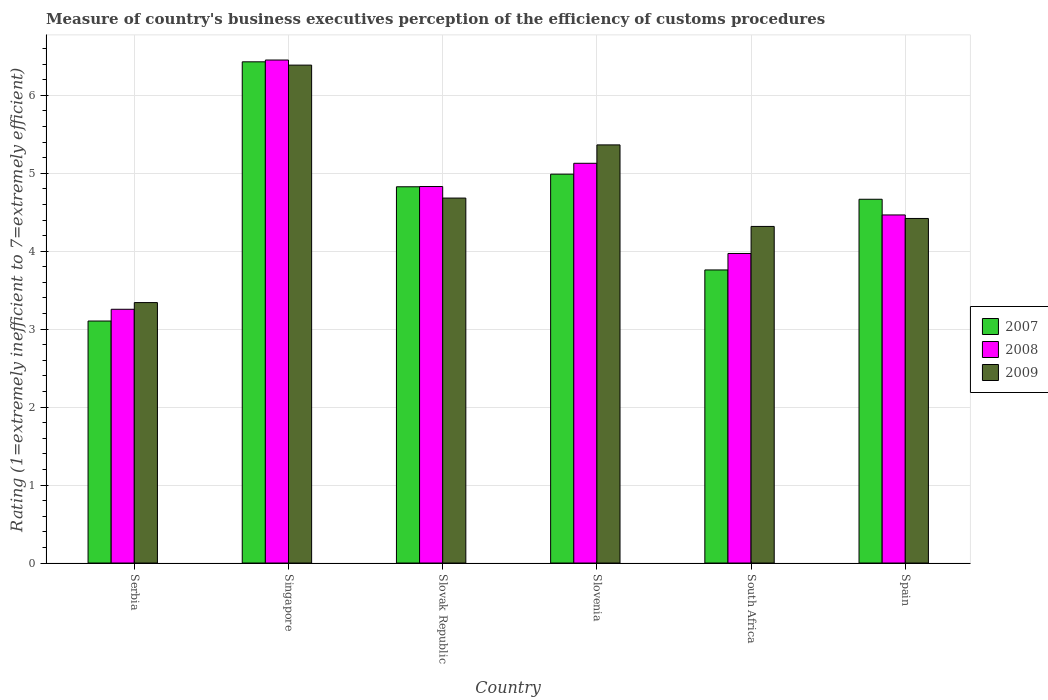How many groups of bars are there?
Your response must be concise. 6. Are the number of bars per tick equal to the number of legend labels?
Offer a very short reply. Yes. How many bars are there on the 5th tick from the left?
Your response must be concise. 3. What is the label of the 2nd group of bars from the left?
Provide a succinct answer. Singapore. What is the rating of the efficiency of customs procedure in 2007 in Slovak Republic?
Keep it short and to the point. 4.83. Across all countries, what is the maximum rating of the efficiency of customs procedure in 2009?
Make the answer very short. 6.39. Across all countries, what is the minimum rating of the efficiency of customs procedure in 2009?
Offer a terse response. 3.34. In which country was the rating of the efficiency of customs procedure in 2009 maximum?
Give a very brief answer. Singapore. In which country was the rating of the efficiency of customs procedure in 2008 minimum?
Your answer should be compact. Serbia. What is the total rating of the efficiency of customs procedure in 2007 in the graph?
Your answer should be compact. 27.78. What is the difference between the rating of the efficiency of customs procedure in 2007 in Slovak Republic and that in Slovenia?
Your answer should be very brief. -0.16. What is the difference between the rating of the efficiency of customs procedure in 2008 in Slovak Republic and the rating of the efficiency of customs procedure in 2007 in South Africa?
Ensure brevity in your answer.  1.07. What is the average rating of the efficiency of customs procedure in 2007 per country?
Keep it short and to the point. 4.63. What is the difference between the rating of the efficiency of customs procedure of/in 2007 and rating of the efficiency of customs procedure of/in 2008 in Slovenia?
Ensure brevity in your answer.  -0.14. In how many countries, is the rating of the efficiency of customs procedure in 2008 greater than 2.6?
Provide a short and direct response. 6. What is the ratio of the rating of the efficiency of customs procedure in 2009 in Serbia to that in Singapore?
Offer a terse response. 0.52. Is the rating of the efficiency of customs procedure in 2008 in Serbia less than that in Slovenia?
Offer a terse response. Yes. Is the difference between the rating of the efficiency of customs procedure in 2007 in Serbia and South Africa greater than the difference between the rating of the efficiency of customs procedure in 2008 in Serbia and South Africa?
Keep it short and to the point. Yes. What is the difference between the highest and the second highest rating of the efficiency of customs procedure in 2007?
Ensure brevity in your answer.  0.16. What is the difference between the highest and the lowest rating of the efficiency of customs procedure in 2009?
Your response must be concise. 3.05. How many bars are there?
Offer a terse response. 18. Are all the bars in the graph horizontal?
Give a very brief answer. No. How many countries are there in the graph?
Provide a succinct answer. 6. Are the values on the major ticks of Y-axis written in scientific E-notation?
Keep it short and to the point. No. Where does the legend appear in the graph?
Your response must be concise. Center right. What is the title of the graph?
Your answer should be very brief. Measure of country's business executives perception of the efficiency of customs procedures. What is the label or title of the X-axis?
Provide a short and direct response. Country. What is the label or title of the Y-axis?
Your response must be concise. Rating (1=extremely inefficient to 7=extremely efficient). What is the Rating (1=extremely inefficient to 7=extremely efficient) in 2007 in Serbia?
Your response must be concise. 3.1. What is the Rating (1=extremely inefficient to 7=extremely efficient) of 2008 in Serbia?
Your answer should be compact. 3.26. What is the Rating (1=extremely inefficient to 7=extremely efficient) of 2009 in Serbia?
Your answer should be very brief. 3.34. What is the Rating (1=extremely inefficient to 7=extremely efficient) of 2007 in Singapore?
Your response must be concise. 6.43. What is the Rating (1=extremely inefficient to 7=extremely efficient) in 2008 in Singapore?
Your response must be concise. 6.45. What is the Rating (1=extremely inefficient to 7=extremely efficient) of 2009 in Singapore?
Give a very brief answer. 6.39. What is the Rating (1=extremely inefficient to 7=extremely efficient) in 2007 in Slovak Republic?
Make the answer very short. 4.83. What is the Rating (1=extremely inefficient to 7=extremely efficient) of 2008 in Slovak Republic?
Your answer should be very brief. 4.83. What is the Rating (1=extremely inefficient to 7=extremely efficient) in 2009 in Slovak Republic?
Offer a terse response. 4.68. What is the Rating (1=extremely inefficient to 7=extremely efficient) of 2007 in Slovenia?
Provide a short and direct response. 4.99. What is the Rating (1=extremely inefficient to 7=extremely efficient) in 2008 in Slovenia?
Keep it short and to the point. 5.13. What is the Rating (1=extremely inefficient to 7=extremely efficient) of 2009 in Slovenia?
Provide a succinct answer. 5.36. What is the Rating (1=extremely inefficient to 7=extremely efficient) of 2007 in South Africa?
Provide a succinct answer. 3.76. What is the Rating (1=extremely inefficient to 7=extremely efficient) of 2008 in South Africa?
Ensure brevity in your answer.  3.97. What is the Rating (1=extremely inefficient to 7=extremely efficient) of 2009 in South Africa?
Keep it short and to the point. 4.32. What is the Rating (1=extremely inefficient to 7=extremely efficient) in 2007 in Spain?
Your response must be concise. 4.67. What is the Rating (1=extremely inefficient to 7=extremely efficient) of 2008 in Spain?
Make the answer very short. 4.47. What is the Rating (1=extremely inefficient to 7=extremely efficient) in 2009 in Spain?
Give a very brief answer. 4.42. Across all countries, what is the maximum Rating (1=extremely inefficient to 7=extremely efficient) of 2007?
Offer a terse response. 6.43. Across all countries, what is the maximum Rating (1=extremely inefficient to 7=extremely efficient) of 2008?
Keep it short and to the point. 6.45. Across all countries, what is the maximum Rating (1=extremely inefficient to 7=extremely efficient) of 2009?
Your response must be concise. 6.39. Across all countries, what is the minimum Rating (1=extremely inefficient to 7=extremely efficient) of 2007?
Your answer should be very brief. 3.1. Across all countries, what is the minimum Rating (1=extremely inefficient to 7=extremely efficient) in 2008?
Provide a short and direct response. 3.26. Across all countries, what is the minimum Rating (1=extremely inefficient to 7=extremely efficient) of 2009?
Keep it short and to the point. 3.34. What is the total Rating (1=extremely inefficient to 7=extremely efficient) of 2007 in the graph?
Your answer should be very brief. 27.78. What is the total Rating (1=extremely inefficient to 7=extremely efficient) in 2008 in the graph?
Your answer should be very brief. 28.1. What is the total Rating (1=extremely inefficient to 7=extremely efficient) of 2009 in the graph?
Make the answer very short. 28.51. What is the difference between the Rating (1=extremely inefficient to 7=extremely efficient) in 2007 in Serbia and that in Singapore?
Provide a short and direct response. -3.33. What is the difference between the Rating (1=extremely inefficient to 7=extremely efficient) of 2008 in Serbia and that in Singapore?
Your response must be concise. -3.2. What is the difference between the Rating (1=extremely inefficient to 7=extremely efficient) in 2009 in Serbia and that in Singapore?
Your response must be concise. -3.05. What is the difference between the Rating (1=extremely inefficient to 7=extremely efficient) of 2007 in Serbia and that in Slovak Republic?
Ensure brevity in your answer.  -1.72. What is the difference between the Rating (1=extremely inefficient to 7=extremely efficient) of 2008 in Serbia and that in Slovak Republic?
Provide a short and direct response. -1.57. What is the difference between the Rating (1=extremely inefficient to 7=extremely efficient) in 2009 in Serbia and that in Slovak Republic?
Provide a short and direct response. -1.34. What is the difference between the Rating (1=extremely inefficient to 7=extremely efficient) in 2007 in Serbia and that in Slovenia?
Your answer should be compact. -1.88. What is the difference between the Rating (1=extremely inefficient to 7=extremely efficient) of 2008 in Serbia and that in Slovenia?
Offer a very short reply. -1.87. What is the difference between the Rating (1=extremely inefficient to 7=extremely efficient) in 2009 in Serbia and that in Slovenia?
Your response must be concise. -2.02. What is the difference between the Rating (1=extremely inefficient to 7=extremely efficient) in 2007 in Serbia and that in South Africa?
Keep it short and to the point. -0.66. What is the difference between the Rating (1=extremely inefficient to 7=extremely efficient) of 2008 in Serbia and that in South Africa?
Offer a very short reply. -0.72. What is the difference between the Rating (1=extremely inefficient to 7=extremely efficient) of 2009 in Serbia and that in South Africa?
Give a very brief answer. -0.98. What is the difference between the Rating (1=extremely inefficient to 7=extremely efficient) of 2007 in Serbia and that in Spain?
Keep it short and to the point. -1.56. What is the difference between the Rating (1=extremely inefficient to 7=extremely efficient) in 2008 in Serbia and that in Spain?
Offer a terse response. -1.21. What is the difference between the Rating (1=extremely inefficient to 7=extremely efficient) in 2009 in Serbia and that in Spain?
Make the answer very short. -1.08. What is the difference between the Rating (1=extremely inefficient to 7=extremely efficient) of 2007 in Singapore and that in Slovak Republic?
Your answer should be compact. 1.6. What is the difference between the Rating (1=extremely inefficient to 7=extremely efficient) of 2008 in Singapore and that in Slovak Republic?
Your response must be concise. 1.62. What is the difference between the Rating (1=extremely inefficient to 7=extremely efficient) of 2009 in Singapore and that in Slovak Republic?
Your answer should be very brief. 1.71. What is the difference between the Rating (1=extremely inefficient to 7=extremely efficient) of 2007 in Singapore and that in Slovenia?
Give a very brief answer. 1.44. What is the difference between the Rating (1=extremely inefficient to 7=extremely efficient) of 2008 in Singapore and that in Slovenia?
Make the answer very short. 1.32. What is the difference between the Rating (1=extremely inefficient to 7=extremely efficient) of 2009 in Singapore and that in Slovenia?
Ensure brevity in your answer.  1.02. What is the difference between the Rating (1=extremely inefficient to 7=extremely efficient) in 2007 in Singapore and that in South Africa?
Ensure brevity in your answer.  2.67. What is the difference between the Rating (1=extremely inefficient to 7=extremely efficient) in 2008 in Singapore and that in South Africa?
Your response must be concise. 2.48. What is the difference between the Rating (1=extremely inefficient to 7=extremely efficient) in 2009 in Singapore and that in South Africa?
Provide a short and direct response. 2.07. What is the difference between the Rating (1=extremely inefficient to 7=extremely efficient) in 2007 in Singapore and that in Spain?
Your answer should be compact. 1.76. What is the difference between the Rating (1=extremely inefficient to 7=extremely efficient) of 2008 in Singapore and that in Spain?
Your answer should be very brief. 1.99. What is the difference between the Rating (1=extremely inefficient to 7=extremely efficient) of 2009 in Singapore and that in Spain?
Your answer should be very brief. 1.97. What is the difference between the Rating (1=extremely inefficient to 7=extremely efficient) of 2007 in Slovak Republic and that in Slovenia?
Provide a short and direct response. -0.16. What is the difference between the Rating (1=extremely inefficient to 7=extremely efficient) of 2008 in Slovak Republic and that in Slovenia?
Your answer should be very brief. -0.3. What is the difference between the Rating (1=extremely inefficient to 7=extremely efficient) in 2009 in Slovak Republic and that in Slovenia?
Give a very brief answer. -0.68. What is the difference between the Rating (1=extremely inefficient to 7=extremely efficient) of 2007 in Slovak Republic and that in South Africa?
Keep it short and to the point. 1.07. What is the difference between the Rating (1=extremely inefficient to 7=extremely efficient) of 2008 in Slovak Republic and that in South Africa?
Ensure brevity in your answer.  0.86. What is the difference between the Rating (1=extremely inefficient to 7=extremely efficient) in 2009 in Slovak Republic and that in South Africa?
Ensure brevity in your answer.  0.36. What is the difference between the Rating (1=extremely inefficient to 7=extremely efficient) in 2007 in Slovak Republic and that in Spain?
Keep it short and to the point. 0.16. What is the difference between the Rating (1=extremely inefficient to 7=extremely efficient) in 2008 in Slovak Republic and that in Spain?
Ensure brevity in your answer.  0.36. What is the difference between the Rating (1=extremely inefficient to 7=extremely efficient) of 2009 in Slovak Republic and that in Spain?
Your answer should be compact. 0.26. What is the difference between the Rating (1=extremely inefficient to 7=extremely efficient) of 2007 in Slovenia and that in South Africa?
Ensure brevity in your answer.  1.23. What is the difference between the Rating (1=extremely inefficient to 7=extremely efficient) in 2008 in Slovenia and that in South Africa?
Your response must be concise. 1.16. What is the difference between the Rating (1=extremely inefficient to 7=extremely efficient) of 2009 in Slovenia and that in South Africa?
Offer a very short reply. 1.05. What is the difference between the Rating (1=extremely inefficient to 7=extremely efficient) in 2007 in Slovenia and that in Spain?
Provide a short and direct response. 0.32. What is the difference between the Rating (1=extremely inefficient to 7=extremely efficient) of 2008 in Slovenia and that in Spain?
Your answer should be very brief. 0.66. What is the difference between the Rating (1=extremely inefficient to 7=extremely efficient) of 2009 in Slovenia and that in Spain?
Offer a terse response. 0.94. What is the difference between the Rating (1=extremely inefficient to 7=extremely efficient) of 2007 in South Africa and that in Spain?
Give a very brief answer. -0.91. What is the difference between the Rating (1=extremely inefficient to 7=extremely efficient) in 2008 in South Africa and that in Spain?
Ensure brevity in your answer.  -0.49. What is the difference between the Rating (1=extremely inefficient to 7=extremely efficient) in 2009 in South Africa and that in Spain?
Provide a succinct answer. -0.1. What is the difference between the Rating (1=extremely inefficient to 7=extremely efficient) of 2007 in Serbia and the Rating (1=extremely inefficient to 7=extremely efficient) of 2008 in Singapore?
Keep it short and to the point. -3.35. What is the difference between the Rating (1=extremely inefficient to 7=extremely efficient) of 2007 in Serbia and the Rating (1=extremely inefficient to 7=extremely efficient) of 2009 in Singapore?
Your response must be concise. -3.28. What is the difference between the Rating (1=extremely inefficient to 7=extremely efficient) in 2008 in Serbia and the Rating (1=extremely inefficient to 7=extremely efficient) in 2009 in Singapore?
Provide a short and direct response. -3.13. What is the difference between the Rating (1=extremely inefficient to 7=extremely efficient) of 2007 in Serbia and the Rating (1=extremely inefficient to 7=extremely efficient) of 2008 in Slovak Republic?
Give a very brief answer. -1.73. What is the difference between the Rating (1=extremely inefficient to 7=extremely efficient) in 2007 in Serbia and the Rating (1=extremely inefficient to 7=extremely efficient) in 2009 in Slovak Republic?
Ensure brevity in your answer.  -1.58. What is the difference between the Rating (1=extremely inefficient to 7=extremely efficient) of 2008 in Serbia and the Rating (1=extremely inefficient to 7=extremely efficient) of 2009 in Slovak Republic?
Provide a succinct answer. -1.43. What is the difference between the Rating (1=extremely inefficient to 7=extremely efficient) of 2007 in Serbia and the Rating (1=extremely inefficient to 7=extremely efficient) of 2008 in Slovenia?
Keep it short and to the point. -2.02. What is the difference between the Rating (1=extremely inefficient to 7=extremely efficient) in 2007 in Serbia and the Rating (1=extremely inefficient to 7=extremely efficient) in 2009 in Slovenia?
Provide a succinct answer. -2.26. What is the difference between the Rating (1=extremely inefficient to 7=extremely efficient) in 2008 in Serbia and the Rating (1=extremely inefficient to 7=extremely efficient) in 2009 in Slovenia?
Your answer should be compact. -2.11. What is the difference between the Rating (1=extremely inefficient to 7=extremely efficient) of 2007 in Serbia and the Rating (1=extremely inefficient to 7=extremely efficient) of 2008 in South Africa?
Ensure brevity in your answer.  -0.87. What is the difference between the Rating (1=extremely inefficient to 7=extremely efficient) of 2007 in Serbia and the Rating (1=extremely inefficient to 7=extremely efficient) of 2009 in South Africa?
Make the answer very short. -1.21. What is the difference between the Rating (1=extremely inefficient to 7=extremely efficient) of 2008 in Serbia and the Rating (1=extremely inefficient to 7=extremely efficient) of 2009 in South Africa?
Offer a very short reply. -1.06. What is the difference between the Rating (1=extremely inefficient to 7=extremely efficient) of 2007 in Serbia and the Rating (1=extremely inefficient to 7=extremely efficient) of 2008 in Spain?
Offer a terse response. -1.36. What is the difference between the Rating (1=extremely inefficient to 7=extremely efficient) in 2007 in Serbia and the Rating (1=extremely inefficient to 7=extremely efficient) in 2009 in Spain?
Ensure brevity in your answer.  -1.32. What is the difference between the Rating (1=extremely inefficient to 7=extremely efficient) of 2008 in Serbia and the Rating (1=extremely inefficient to 7=extremely efficient) of 2009 in Spain?
Your answer should be very brief. -1.17. What is the difference between the Rating (1=extremely inefficient to 7=extremely efficient) in 2007 in Singapore and the Rating (1=extremely inefficient to 7=extremely efficient) in 2008 in Slovak Republic?
Provide a succinct answer. 1.6. What is the difference between the Rating (1=extremely inefficient to 7=extremely efficient) in 2007 in Singapore and the Rating (1=extremely inefficient to 7=extremely efficient) in 2009 in Slovak Republic?
Give a very brief answer. 1.75. What is the difference between the Rating (1=extremely inefficient to 7=extremely efficient) in 2008 in Singapore and the Rating (1=extremely inefficient to 7=extremely efficient) in 2009 in Slovak Republic?
Provide a succinct answer. 1.77. What is the difference between the Rating (1=extremely inefficient to 7=extremely efficient) of 2007 in Singapore and the Rating (1=extremely inefficient to 7=extremely efficient) of 2008 in Slovenia?
Offer a very short reply. 1.3. What is the difference between the Rating (1=extremely inefficient to 7=extremely efficient) of 2007 in Singapore and the Rating (1=extremely inefficient to 7=extremely efficient) of 2009 in Slovenia?
Make the answer very short. 1.07. What is the difference between the Rating (1=extremely inefficient to 7=extremely efficient) of 2008 in Singapore and the Rating (1=extremely inefficient to 7=extremely efficient) of 2009 in Slovenia?
Ensure brevity in your answer.  1.09. What is the difference between the Rating (1=extremely inefficient to 7=extremely efficient) of 2007 in Singapore and the Rating (1=extremely inefficient to 7=extremely efficient) of 2008 in South Africa?
Give a very brief answer. 2.46. What is the difference between the Rating (1=extremely inefficient to 7=extremely efficient) in 2007 in Singapore and the Rating (1=extremely inefficient to 7=extremely efficient) in 2009 in South Africa?
Keep it short and to the point. 2.11. What is the difference between the Rating (1=extremely inefficient to 7=extremely efficient) of 2008 in Singapore and the Rating (1=extremely inefficient to 7=extremely efficient) of 2009 in South Africa?
Provide a short and direct response. 2.13. What is the difference between the Rating (1=extremely inefficient to 7=extremely efficient) of 2007 in Singapore and the Rating (1=extremely inefficient to 7=extremely efficient) of 2008 in Spain?
Keep it short and to the point. 1.96. What is the difference between the Rating (1=extremely inefficient to 7=extremely efficient) of 2007 in Singapore and the Rating (1=extremely inefficient to 7=extremely efficient) of 2009 in Spain?
Provide a succinct answer. 2.01. What is the difference between the Rating (1=extremely inefficient to 7=extremely efficient) in 2008 in Singapore and the Rating (1=extremely inefficient to 7=extremely efficient) in 2009 in Spain?
Ensure brevity in your answer.  2.03. What is the difference between the Rating (1=extremely inefficient to 7=extremely efficient) in 2007 in Slovak Republic and the Rating (1=extremely inefficient to 7=extremely efficient) in 2008 in Slovenia?
Your answer should be compact. -0.3. What is the difference between the Rating (1=extremely inefficient to 7=extremely efficient) of 2007 in Slovak Republic and the Rating (1=extremely inefficient to 7=extremely efficient) of 2009 in Slovenia?
Your answer should be very brief. -0.54. What is the difference between the Rating (1=extremely inefficient to 7=extremely efficient) in 2008 in Slovak Republic and the Rating (1=extremely inefficient to 7=extremely efficient) in 2009 in Slovenia?
Provide a succinct answer. -0.53. What is the difference between the Rating (1=extremely inefficient to 7=extremely efficient) of 2007 in Slovak Republic and the Rating (1=extremely inefficient to 7=extremely efficient) of 2008 in South Africa?
Your answer should be compact. 0.86. What is the difference between the Rating (1=extremely inefficient to 7=extremely efficient) in 2007 in Slovak Republic and the Rating (1=extremely inefficient to 7=extremely efficient) in 2009 in South Africa?
Provide a short and direct response. 0.51. What is the difference between the Rating (1=extremely inefficient to 7=extremely efficient) of 2008 in Slovak Republic and the Rating (1=extremely inefficient to 7=extremely efficient) of 2009 in South Africa?
Provide a succinct answer. 0.51. What is the difference between the Rating (1=extremely inefficient to 7=extremely efficient) in 2007 in Slovak Republic and the Rating (1=extremely inefficient to 7=extremely efficient) in 2008 in Spain?
Your response must be concise. 0.36. What is the difference between the Rating (1=extremely inefficient to 7=extremely efficient) of 2007 in Slovak Republic and the Rating (1=extremely inefficient to 7=extremely efficient) of 2009 in Spain?
Your answer should be very brief. 0.41. What is the difference between the Rating (1=extremely inefficient to 7=extremely efficient) of 2008 in Slovak Republic and the Rating (1=extremely inefficient to 7=extremely efficient) of 2009 in Spain?
Give a very brief answer. 0.41. What is the difference between the Rating (1=extremely inefficient to 7=extremely efficient) of 2007 in Slovenia and the Rating (1=extremely inefficient to 7=extremely efficient) of 2008 in South Africa?
Keep it short and to the point. 1.02. What is the difference between the Rating (1=extremely inefficient to 7=extremely efficient) of 2007 in Slovenia and the Rating (1=extremely inefficient to 7=extremely efficient) of 2009 in South Africa?
Offer a terse response. 0.67. What is the difference between the Rating (1=extremely inefficient to 7=extremely efficient) in 2008 in Slovenia and the Rating (1=extremely inefficient to 7=extremely efficient) in 2009 in South Africa?
Provide a short and direct response. 0.81. What is the difference between the Rating (1=extremely inefficient to 7=extremely efficient) in 2007 in Slovenia and the Rating (1=extremely inefficient to 7=extremely efficient) in 2008 in Spain?
Provide a succinct answer. 0.52. What is the difference between the Rating (1=extremely inefficient to 7=extremely efficient) in 2007 in Slovenia and the Rating (1=extremely inefficient to 7=extremely efficient) in 2009 in Spain?
Provide a succinct answer. 0.57. What is the difference between the Rating (1=extremely inefficient to 7=extremely efficient) in 2008 in Slovenia and the Rating (1=extremely inefficient to 7=extremely efficient) in 2009 in Spain?
Your answer should be very brief. 0.71. What is the difference between the Rating (1=extremely inefficient to 7=extremely efficient) in 2007 in South Africa and the Rating (1=extremely inefficient to 7=extremely efficient) in 2008 in Spain?
Your answer should be very brief. -0.71. What is the difference between the Rating (1=extremely inefficient to 7=extremely efficient) in 2007 in South Africa and the Rating (1=extremely inefficient to 7=extremely efficient) in 2009 in Spain?
Offer a terse response. -0.66. What is the difference between the Rating (1=extremely inefficient to 7=extremely efficient) in 2008 in South Africa and the Rating (1=extremely inefficient to 7=extremely efficient) in 2009 in Spain?
Keep it short and to the point. -0.45. What is the average Rating (1=extremely inefficient to 7=extremely efficient) of 2007 per country?
Provide a short and direct response. 4.63. What is the average Rating (1=extremely inefficient to 7=extremely efficient) in 2008 per country?
Keep it short and to the point. 4.68. What is the average Rating (1=extremely inefficient to 7=extremely efficient) in 2009 per country?
Your answer should be very brief. 4.75. What is the difference between the Rating (1=extremely inefficient to 7=extremely efficient) in 2007 and Rating (1=extremely inefficient to 7=extremely efficient) in 2008 in Serbia?
Keep it short and to the point. -0.15. What is the difference between the Rating (1=extremely inefficient to 7=extremely efficient) of 2007 and Rating (1=extremely inefficient to 7=extremely efficient) of 2009 in Serbia?
Your answer should be very brief. -0.24. What is the difference between the Rating (1=extremely inefficient to 7=extremely efficient) of 2008 and Rating (1=extremely inefficient to 7=extremely efficient) of 2009 in Serbia?
Offer a terse response. -0.09. What is the difference between the Rating (1=extremely inefficient to 7=extremely efficient) in 2007 and Rating (1=extremely inefficient to 7=extremely efficient) in 2008 in Singapore?
Make the answer very short. -0.02. What is the difference between the Rating (1=extremely inefficient to 7=extremely efficient) of 2007 and Rating (1=extremely inefficient to 7=extremely efficient) of 2009 in Singapore?
Provide a succinct answer. 0.04. What is the difference between the Rating (1=extremely inefficient to 7=extremely efficient) in 2008 and Rating (1=extremely inefficient to 7=extremely efficient) in 2009 in Singapore?
Offer a very short reply. 0.07. What is the difference between the Rating (1=extremely inefficient to 7=extremely efficient) of 2007 and Rating (1=extremely inefficient to 7=extremely efficient) of 2008 in Slovak Republic?
Offer a very short reply. -0. What is the difference between the Rating (1=extremely inefficient to 7=extremely efficient) of 2007 and Rating (1=extremely inefficient to 7=extremely efficient) of 2009 in Slovak Republic?
Your answer should be compact. 0.14. What is the difference between the Rating (1=extremely inefficient to 7=extremely efficient) in 2008 and Rating (1=extremely inefficient to 7=extremely efficient) in 2009 in Slovak Republic?
Give a very brief answer. 0.15. What is the difference between the Rating (1=extremely inefficient to 7=extremely efficient) in 2007 and Rating (1=extremely inefficient to 7=extremely efficient) in 2008 in Slovenia?
Provide a succinct answer. -0.14. What is the difference between the Rating (1=extremely inefficient to 7=extremely efficient) in 2007 and Rating (1=extremely inefficient to 7=extremely efficient) in 2009 in Slovenia?
Offer a terse response. -0.38. What is the difference between the Rating (1=extremely inefficient to 7=extremely efficient) of 2008 and Rating (1=extremely inefficient to 7=extremely efficient) of 2009 in Slovenia?
Provide a succinct answer. -0.24. What is the difference between the Rating (1=extremely inefficient to 7=extremely efficient) of 2007 and Rating (1=extremely inefficient to 7=extremely efficient) of 2008 in South Africa?
Ensure brevity in your answer.  -0.21. What is the difference between the Rating (1=extremely inefficient to 7=extremely efficient) in 2007 and Rating (1=extremely inefficient to 7=extremely efficient) in 2009 in South Africa?
Offer a very short reply. -0.56. What is the difference between the Rating (1=extremely inefficient to 7=extremely efficient) in 2008 and Rating (1=extremely inefficient to 7=extremely efficient) in 2009 in South Africa?
Offer a very short reply. -0.35. What is the difference between the Rating (1=extremely inefficient to 7=extremely efficient) in 2007 and Rating (1=extremely inefficient to 7=extremely efficient) in 2008 in Spain?
Provide a short and direct response. 0.2. What is the difference between the Rating (1=extremely inefficient to 7=extremely efficient) of 2007 and Rating (1=extremely inefficient to 7=extremely efficient) of 2009 in Spain?
Ensure brevity in your answer.  0.25. What is the difference between the Rating (1=extremely inefficient to 7=extremely efficient) in 2008 and Rating (1=extremely inefficient to 7=extremely efficient) in 2009 in Spain?
Offer a very short reply. 0.05. What is the ratio of the Rating (1=extremely inefficient to 7=extremely efficient) of 2007 in Serbia to that in Singapore?
Make the answer very short. 0.48. What is the ratio of the Rating (1=extremely inefficient to 7=extremely efficient) of 2008 in Serbia to that in Singapore?
Give a very brief answer. 0.5. What is the ratio of the Rating (1=extremely inefficient to 7=extremely efficient) in 2009 in Serbia to that in Singapore?
Ensure brevity in your answer.  0.52. What is the ratio of the Rating (1=extremely inefficient to 7=extremely efficient) of 2007 in Serbia to that in Slovak Republic?
Keep it short and to the point. 0.64. What is the ratio of the Rating (1=extremely inefficient to 7=extremely efficient) in 2008 in Serbia to that in Slovak Republic?
Your response must be concise. 0.67. What is the ratio of the Rating (1=extremely inefficient to 7=extremely efficient) of 2009 in Serbia to that in Slovak Republic?
Make the answer very short. 0.71. What is the ratio of the Rating (1=extremely inefficient to 7=extremely efficient) in 2007 in Serbia to that in Slovenia?
Provide a short and direct response. 0.62. What is the ratio of the Rating (1=extremely inefficient to 7=extremely efficient) of 2008 in Serbia to that in Slovenia?
Provide a short and direct response. 0.63. What is the ratio of the Rating (1=extremely inefficient to 7=extremely efficient) of 2009 in Serbia to that in Slovenia?
Offer a very short reply. 0.62. What is the ratio of the Rating (1=extremely inefficient to 7=extremely efficient) of 2007 in Serbia to that in South Africa?
Your response must be concise. 0.83. What is the ratio of the Rating (1=extremely inefficient to 7=extremely efficient) of 2008 in Serbia to that in South Africa?
Your response must be concise. 0.82. What is the ratio of the Rating (1=extremely inefficient to 7=extremely efficient) of 2009 in Serbia to that in South Africa?
Your answer should be very brief. 0.77. What is the ratio of the Rating (1=extremely inefficient to 7=extremely efficient) of 2007 in Serbia to that in Spain?
Provide a succinct answer. 0.67. What is the ratio of the Rating (1=extremely inefficient to 7=extremely efficient) in 2008 in Serbia to that in Spain?
Your answer should be compact. 0.73. What is the ratio of the Rating (1=extremely inefficient to 7=extremely efficient) of 2009 in Serbia to that in Spain?
Ensure brevity in your answer.  0.76. What is the ratio of the Rating (1=extremely inefficient to 7=extremely efficient) in 2007 in Singapore to that in Slovak Republic?
Offer a terse response. 1.33. What is the ratio of the Rating (1=extremely inefficient to 7=extremely efficient) of 2008 in Singapore to that in Slovak Republic?
Your answer should be very brief. 1.34. What is the ratio of the Rating (1=extremely inefficient to 7=extremely efficient) of 2009 in Singapore to that in Slovak Republic?
Your answer should be compact. 1.36. What is the ratio of the Rating (1=extremely inefficient to 7=extremely efficient) in 2007 in Singapore to that in Slovenia?
Keep it short and to the point. 1.29. What is the ratio of the Rating (1=extremely inefficient to 7=extremely efficient) in 2008 in Singapore to that in Slovenia?
Give a very brief answer. 1.26. What is the ratio of the Rating (1=extremely inefficient to 7=extremely efficient) of 2009 in Singapore to that in Slovenia?
Offer a terse response. 1.19. What is the ratio of the Rating (1=extremely inefficient to 7=extremely efficient) in 2007 in Singapore to that in South Africa?
Offer a very short reply. 1.71. What is the ratio of the Rating (1=extremely inefficient to 7=extremely efficient) in 2008 in Singapore to that in South Africa?
Provide a succinct answer. 1.62. What is the ratio of the Rating (1=extremely inefficient to 7=extremely efficient) of 2009 in Singapore to that in South Africa?
Your answer should be very brief. 1.48. What is the ratio of the Rating (1=extremely inefficient to 7=extremely efficient) of 2007 in Singapore to that in Spain?
Make the answer very short. 1.38. What is the ratio of the Rating (1=extremely inefficient to 7=extremely efficient) of 2008 in Singapore to that in Spain?
Your answer should be compact. 1.45. What is the ratio of the Rating (1=extremely inefficient to 7=extremely efficient) in 2009 in Singapore to that in Spain?
Make the answer very short. 1.45. What is the ratio of the Rating (1=extremely inefficient to 7=extremely efficient) in 2007 in Slovak Republic to that in Slovenia?
Offer a terse response. 0.97. What is the ratio of the Rating (1=extremely inefficient to 7=extremely efficient) in 2008 in Slovak Republic to that in Slovenia?
Your answer should be very brief. 0.94. What is the ratio of the Rating (1=extremely inefficient to 7=extremely efficient) in 2009 in Slovak Republic to that in Slovenia?
Make the answer very short. 0.87. What is the ratio of the Rating (1=extremely inefficient to 7=extremely efficient) of 2007 in Slovak Republic to that in South Africa?
Ensure brevity in your answer.  1.28. What is the ratio of the Rating (1=extremely inefficient to 7=extremely efficient) of 2008 in Slovak Republic to that in South Africa?
Provide a short and direct response. 1.22. What is the ratio of the Rating (1=extremely inefficient to 7=extremely efficient) of 2009 in Slovak Republic to that in South Africa?
Keep it short and to the point. 1.08. What is the ratio of the Rating (1=extremely inefficient to 7=extremely efficient) of 2007 in Slovak Republic to that in Spain?
Keep it short and to the point. 1.03. What is the ratio of the Rating (1=extremely inefficient to 7=extremely efficient) of 2008 in Slovak Republic to that in Spain?
Your response must be concise. 1.08. What is the ratio of the Rating (1=extremely inefficient to 7=extremely efficient) of 2009 in Slovak Republic to that in Spain?
Your answer should be very brief. 1.06. What is the ratio of the Rating (1=extremely inefficient to 7=extremely efficient) of 2007 in Slovenia to that in South Africa?
Ensure brevity in your answer.  1.33. What is the ratio of the Rating (1=extremely inefficient to 7=extremely efficient) of 2008 in Slovenia to that in South Africa?
Offer a very short reply. 1.29. What is the ratio of the Rating (1=extremely inefficient to 7=extremely efficient) in 2009 in Slovenia to that in South Africa?
Offer a terse response. 1.24. What is the ratio of the Rating (1=extremely inefficient to 7=extremely efficient) of 2007 in Slovenia to that in Spain?
Your response must be concise. 1.07. What is the ratio of the Rating (1=extremely inefficient to 7=extremely efficient) in 2008 in Slovenia to that in Spain?
Your answer should be very brief. 1.15. What is the ratio of the Rating (1=extremely inefficient to 7=extremely efficient) in 2009 in Slovenia to that in Spain?
Provide a short and direct response. 1.21. What is the ratio of the Rating (1=extremely inefficient to 7=extremely efficient) in 2007 in South Africa to that in Spain?
Your answer should be very brief. 0.81. What is the ratio of the Rating (1=extremely inefficient to 7=extremely efficient) of 2008 in South Africa to that in Spain?
Provide a short and direct response. 0.89. What is the ratio of the Rating (1=extremely inefficient to 7=extremely efficient) of 2009 in South Africa to that in Spain?
Make the answer very short. 0.98. What is the difference between the highest and the second highest Rating (1=extremely inefficient to 7=extremely efficient) of 2007?
Your answer should be compact. 1.44. What is the difference between the highest and the second highest Rating (1=extremely inefficient to 7=extremely efficient) of 2008?
Your answer should be very brief. 1.32. What is the difference between the highest and the second highest Rating (1=extremely inefficient to 7=extremely efficient) of 2009?
Keep it short and to the point. 1.02. What is the difference between the highest and the lowest Rating (1=extremely inefficient to 7=extremely efficient) of 2007?
Offer a very short reply. 3.33. What is the difference between the highest and the lowest Rating (1=extremely inefficient to 7=extremely efficient) of 2008?
Your answer should be compact. 3.2. What is the difference between the highest and the lowest Rating (1=extremely inefficient to 7=extremely efficient) of 2009?
Offer a terse response. 3.05. 